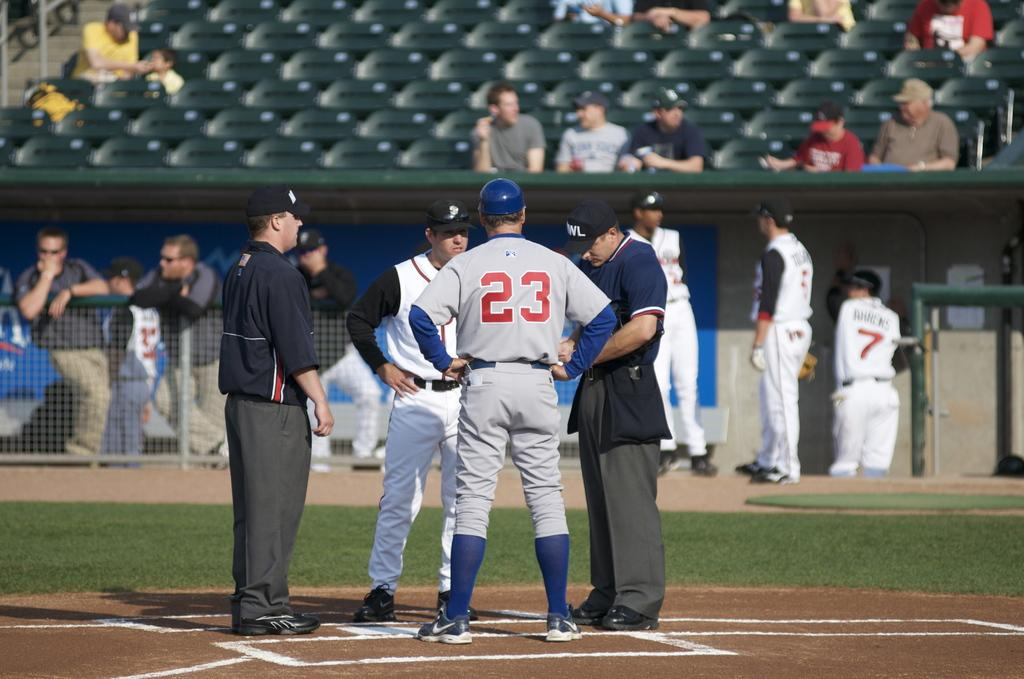<image>
Render a clear and concise summary of the photo. The back of a baseball player's jersey which reads 23, standing talking to some people 